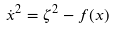<formula> <loc_0><loc_0><loc_500><loc_500>\dot { x } ^ { 2 } = \zeta ^ { 2 } - f ( x )</formula> 